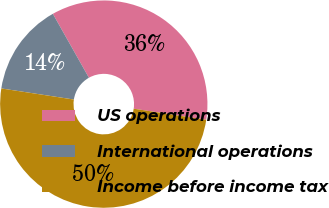<chart> <loc_0><loc_0><loc_500><loc_500><pie_chart><fcel>US operations<fcel>International operations<fcel>Income before income tax<nl><fcel>35.59%<fcel>14.41%<fcel>50.0%<nl></chart> 